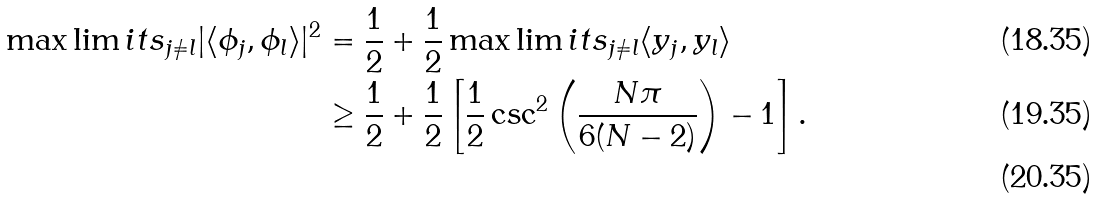Convert formula to latex. <formula><loc_0><loc_0><loc_500><loc_500>\max \lim i t s _ { j \neq l } | \langle \phi _ { j } , \phi _ { l } \rangle | ^ { 2 } & = \frac { 1 } { 2 } + \frac { 1 } { 2 } \max \lim i t s _ { j \neq l } \langle y _ { j } , y _ { l } \rangle \\ & \geq \frac { 1 } { 2 } + \frac { 1 } { 2 } \left [ \frac { 1 } { 2 } \csc ^ { 2 } \left ( \frac { N \pi } { 6 ( N - 2 ) } \right ) - 1 \right ] . \\</formula> 